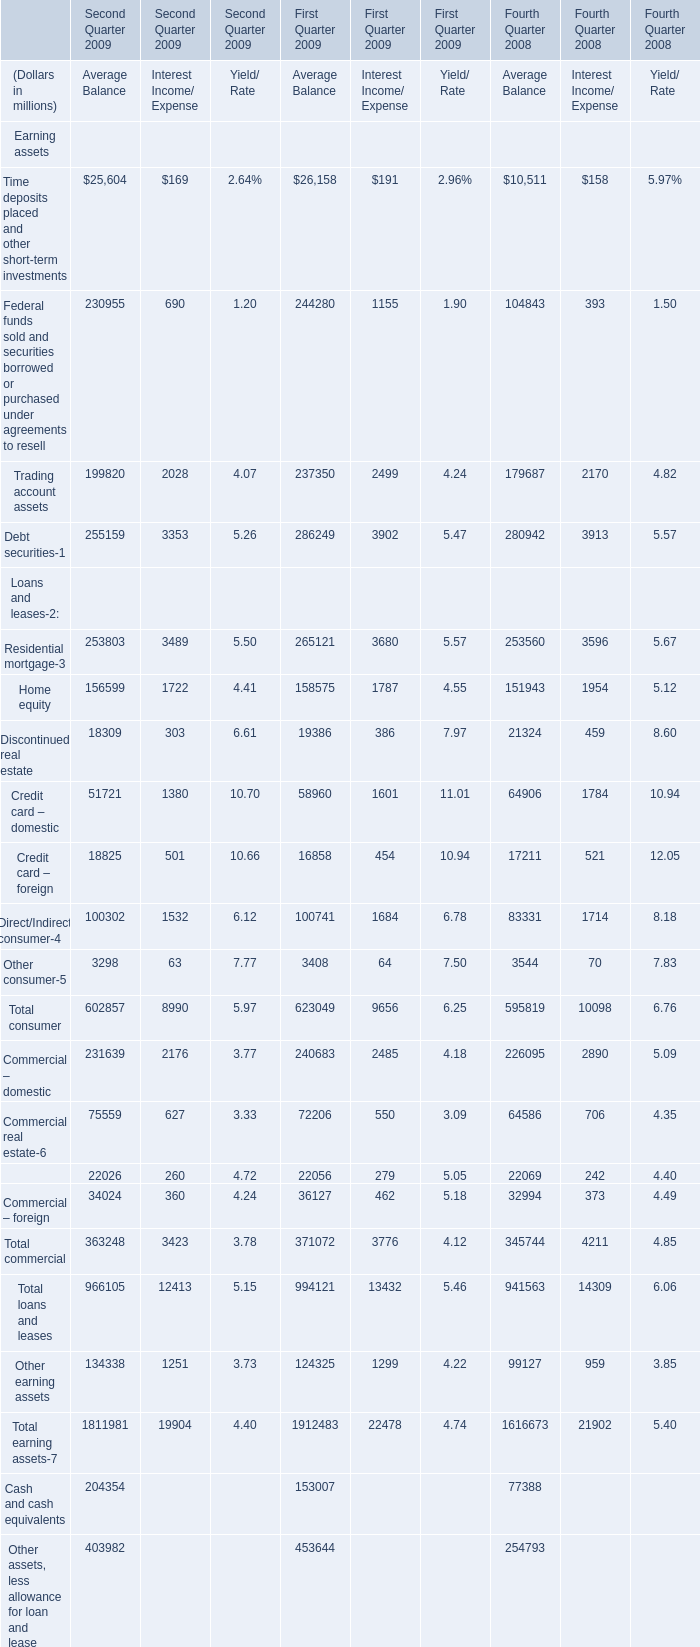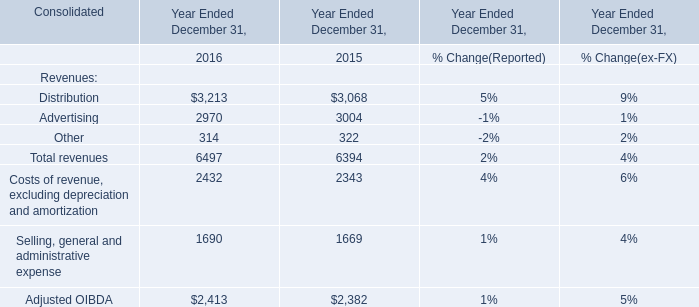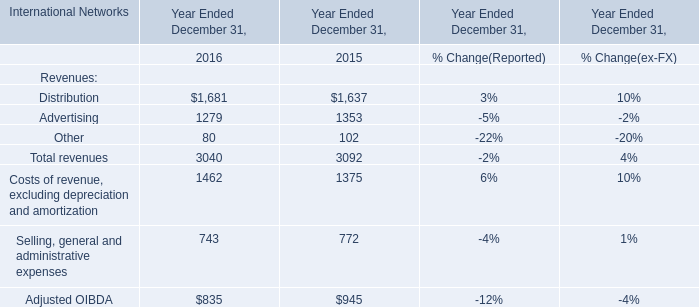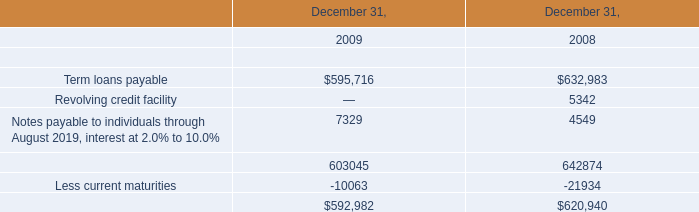What's the average of the Total revenues in the years where Other for Revenues is positive? 
Computations: ((6497 + 6394) / 2)
Answer: 6445.5. 